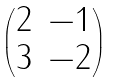<formula> <loc_0><loc_0><loc_500><loc_500>\begin{pmatrix} 2 & - 1 \\ 3 & - 2 \end{pmatrix}</formula> 